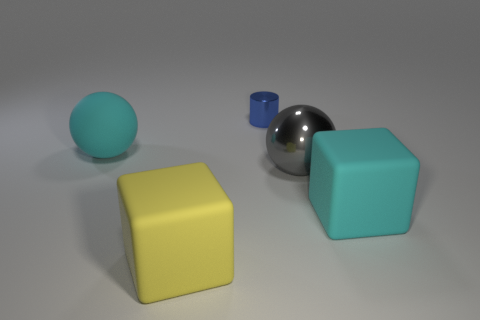How many objects are either big yellow rubber things in front of the large metallic thing or brown metal cubes?
Keep it short and to the point. 1. Is there anything else that is the same size as the yellow matte block?
Ensure brevity in your answer.  Yes. There is a big cyan object behind the gray metal object in front of the rubber ball; what is it made of?
Your response must be concise. Rubber. Are there the same number of tiny cylinders that are in front of the yellow block and small blue metallic things that are right of the gray metal thing?
Your answer should be compact. Yes. How many things are either big balls on the right side of the tiny cylinder or large objects in front of the cyan matte block?
Provide a short and direct response. 2. What is the big object that is to the left of the large gray thing and to the right of the cyan rubber ball made of?
Provide a succinct answer. Rubber. How big is the cyan object on the left side of the big yellow thing to the left of the rubber cube right of the small blue metallic cylinder?
Provide a short and direct response. Large. Are there more tiny blue cylinders than big rubber blocks?
Your answer should be compact. No. Is the material of the large cube that is to the right of the small blue shiny thing the same as the large gray thing?
Your response must be concise. No. Are there fewer large cyan rubber objects than tiny blue metallic cylinders?
Your response must be concise. No. 